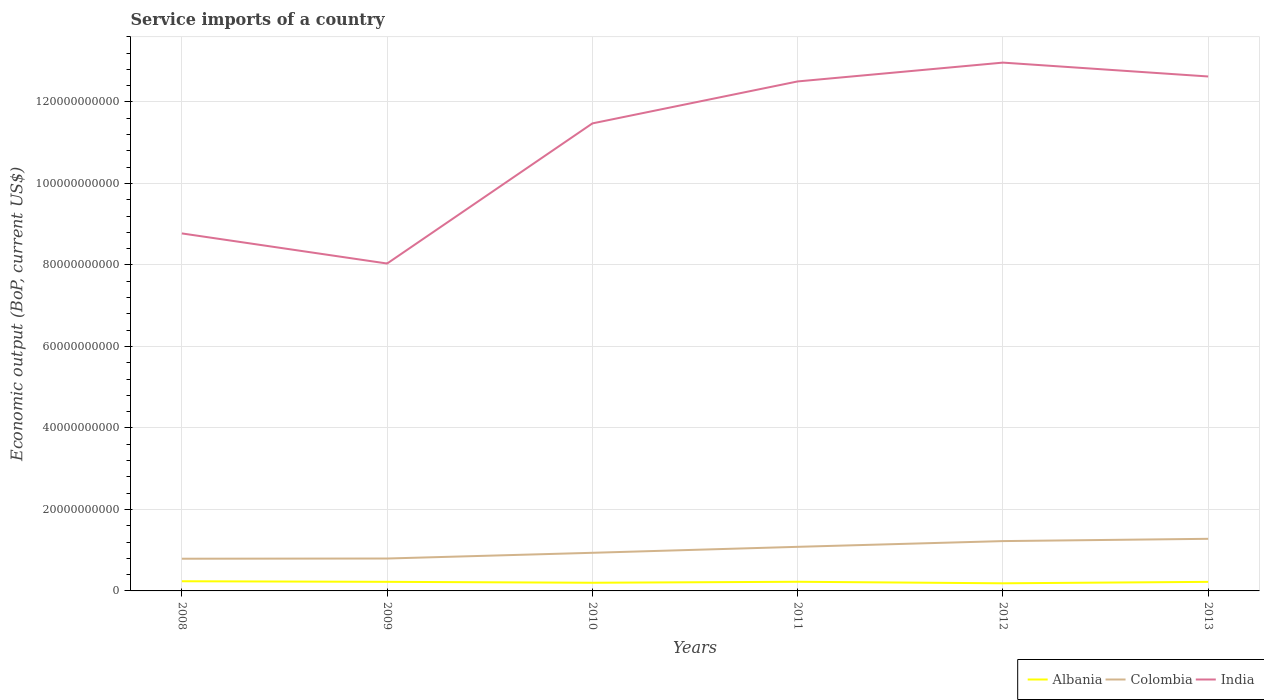How many different coloured lines are there?
Offer a terse response. 3. Does the line corresponding to India intersect with the line corresponding to Albania?
Provide a short and direct response. No. Is the number of lines equal to the number of legend labels?
Your answer should be compact. Yes. Across all years, what is the maximum service imports in India?
Your answer should be compact. 8.03e+1. What is the total service imports in India in the graph?
Make the answer very short. -4.59e+1. What is the difference between the highest and the second highest service imports in Albania?
Give a very brief answer. 5.01e+08. What is the difference between the highest and the lowest service imports in Colombia?
Offer a very short reply. 3. How many lines are there?
Your response must be concise. 3. How many years are there in the graph?
Provide a short and direct response. 6. Are the values on the major ticks of Y-axis written in scientific E-notation?
Ensure brevity in your answer.  No. Does the graph contain any zero values?
Make the answer very short. No. Where does the legend appear in the graph?
Your answer should be compact. Bottom right. How many legend labels are there?
Your answer should be compact. 3. What is the title of the graph?
Provide a succinct answer. Service imports of a country. Does "Equatorial Guinea" appear as one of the legend labels in the graph?
Ensure brevity in your answer.  No. What is the label or title of the Y-axis?
Offer a terse response. Economic output (BoP, current US$). What is the Economic output (BoP, current US$) in Albania in 2008?
Provide a short and direct response. 2.37e+09. What is the Economic output (BoP, current US$) of Colombia in 2008?
Provide a succinct answer. 7.90e+09. What is the Economic output (BoP, current US$) in India in 2008?
Your answer should be compact. 8.77e+1. What is the Economic output (BoP, current US$) of Albania in 2009?
Provide a short and direct response. 2.23e+09. What is the Economic output (BoP, current US$) of Colombia in 2009?
Your answer should be very brief. 7.95e+09. What is the Economic output (BoP, current US$) in India in 2009?
Keep it short and to the point. 8.03e+1. What is the Economic output (BoP, current US$) of Albania in 2010?
Give a very brief answer. 2.01e+09. What is the Economic output (BoP, current US$) of Colombia in 2010?
Your answer should be compact. 9.36e+09. What is the Economic output (BoP, current US$) in India in 2010?
Provide a succinct answer. 1.15e+11. What is the Economic output (BoP, current US$) in Albania in 2011?
Ensure brevity in your answer.  2.25e+09. What is the Economic output (BoP, current US$) in Colombia in 2011?
Your answer should be very brief. 1.08e+1. What is the Economic output (BoP, current US$) in India in 2011?
Offer a terse response. 1.25e+11. What is the Economic output (BoP, current US$) of Albania in 2012?
Keep it short and to the point. 1.87e+09. What is the Economic output (BoP, current US$) of Colombia in 2012?
Provide a succinct answer. 1.22e+1. What is the Economic output (BoP, current US$) in India in 2012?
Ensure brevity in your answer.  1.30e+11. What is the Economic output (BoP, current US$) of Albania in 2013?
Make the answer very short. 2.23e+09. What is the Economic output (BoP, current US$) of Colombia in 2013?
Your answer should be very brief. 1.28e+1. What is the Economic output (BoP, current US$) of India in 2013?
Offer a terse response. 1.26e+11. Across all years, what is the maximum Economic output (BoP, current US$) of Albania?
Ensure brevity in your answer.  2.37e+09. Across all years, what is the maximum Economic output (BoP, current US$) of Colombia?
Make the answer very short. 1.28e+1. Across all years, what is the maximum Economic output (BoP, current US$) of India?
Offer a very short reply. 1.30e+11. Across all years, what is the minimum Economic output (BoP, current US$) in Albania?
Make the answer very short. 1.87e+09. Across all years, what is the minimum Economic output (BoP, current US$) of Colombia?
Offer a very short reply. 7.90e+09. Across all years, what is the minimum Economic output (BoP, current US$) of India?
Offer a very short reply. 8.03e+1. What is the total Economic output (BoP, current US$) of Albania in the graph?
Give a very brief answer. 1.30e+1. What is the total Economic output (BoP, current US$) in Colombia in the graph?
Keep it short and to the point. 6.11e+1. What is the total Economic output (BoP, current US$) in India in the graph?
Ensure brevity in your answer.  6.64e+11. What is the difference between the Economic output (BoP, current US$) of Albania in 2008 and that in 2009?
Ensure brevity in your answer.  1.40e+08. What is the difference between the Economic output (BoP, current US$) in Colombia in 2008 and that in 2009?
Provide a short and direct response. -5.14e+07. What is the difference between the Economic output (BoP, current US$) in India in 2008 and that in 2009?
Keep it short and to the point. 7.39e+09. What is the difference between the Economic output (BoP, current US$) in Albania in 2008 and that in 2010?
Offer a very short reply. 3.65e+08. What is the difference between the Economic output (BoP, current US$) of Colombia in 2008 and that in 2010?
Ensure brevity in your answer.  -1.45e+09. What is the difference between the Economic output (BoP, current US$) of India in 2008 and that in 2010?
Make the answer very short. -2.70e+1. What is the difference between the Economic output (BoP, current US$) of Albania in 2008 and that in 2011?
Ensure brevity in your answer.  1.24e+08. What is the difference between the Economic output (BoP, current US$) in Colombia in 2008 and that in 2011?
Offer a very short reply. -2.92e+09. What is the difference between the Economic output (BoP, current US$) in India in 2008 and that in 2011?
Your answer should be compact. -3.73e+1. What is the difference between the Economic output (BoP, current US$) in Albania in 2008 and that in 2012?
Your response must be concise. 5.01e+08. What is the difference between the Economic output (BoP, current US$) in Colombia in 2008 and that in 2012?
Keep it short and to the point. -4.33e+09. What is the difference between the Economic output (BoP, current US$) of India in 2008 and that in 2012?
Keep it short and to the point. -4.19e+1. What is the difference between the Economic output (BoP, current US$) of Albania in 2008 and that in 2013?
Your answer should be very brief. 1.47e+08. What is the difference between the Economic output (BoP, current US$) of Colombia in 2008 and that in 2013?
Provide a short and direct response. -4.89e+09. What is the difference between the Economic output (BoP, current US$) of India in 2008 and that in 2013?
Give a very brief answer. -3.85e+1. What is the difference between the Economic output (BoP, current US$) in Albania in 2009 and that in 2010?
Ensure brevity in your answer.  2.26e+08. What is the difference between the Economic output (BoP, current US$) in Colombia in 2009 and that in 2010?
Give a very brief answer. -1.40e+09. What is the difference between the Economic output (BoP, current US$) of India in 2009 and that in 2010?
Your answer should be compact. -3.44e+1. What is the difference between the Economic output (BoP, current US$) of Albania in 2009 and that in 2011?
Your answer should be very brief. -1.58e+07. What is the difference between the Economic output (BoP, current US$) in Colombia in 2009 and that in 2011?
Offer a very short reply. -2.87e+09. What is the difference between the Economic output (BoP, current US$) in India in 2009 and that in 2011?
Offer a terse response. -4.47e+1. What is the difference between the Economic output (BoP, current US$) of Albania in 2009 and that in 2012?
Provide a succinct answer. 3.61e+08. What is the difference between the Economic output (BoP, current US$) in Colombia in 2009 and that in 2012?
Your response must be concise. -4.28e+09. What is the difference between the Economic output (BoP, current US$) of India in 2009 and that in 2012?
Your answer should be very brief. -4.93e+1. What is the difference between the Economic output (BoP, current US$) of Albania in 2009 and that in 2013?
Ensure brevity in your answer.  7.36e+06. What is the difference between the Economic output (BoP, current US$) in Colombia in 2009 and that in 2013?
Ensure brevity in your answer.  -4.83e+09. What is the difference between the Economic output (BoP, current US$) in India in 2009 and that in 2013?
Offer a terse response. -4.59e+1. What is the difference between the Economic output (BoP, current US$) of Albania in 2010 and that in 2011?
Keep it short and to the point. -2.42e+08. What is the difference between the Economic output (BoP, current US$) of Colombia in 2010 and that in 2011?
Your answer should be compact. -1.47e+09. What is the difference between the Economic output (BoP, current US$) in India in 2010 and that in 2011?
Provide a succinct answer. -1.03e+1. What is the difference between the Economic output (BoP, current US$) of Albania in 2010 and that in 2012?
Your response must be concise. 1.36e+08. What is the difference between the Economic output (BoP, current US$) in Colombia in 2010 and that in 2012?
Give a very brief answer. -2.87e+09. What is the difference between the Economic output (BoP, current US$) in India in 2010 and that in 2012?
Ensure brevity in your answer.  -1.49e+1. What is the difference between the Economic output (BoP, current US$) of Albania in 2010 and that in 2013?
Offer a terse response. -2.18e+08. What is the difference between the Economic output (BoP, current US$) in Colombia in 2010 and that in 2013?
Your answer should be very brief. -3.43e+09. What is the difference between the Economic output (BoP, current US$) in India in 2010 and that in 2013?
Give a very brief answer. -1.15e+1. What is the difference between the Economic output (BoP, current US$) of Albania in 2011 and that in 2012?
Ensure brevity in your answer.  3.77e+08. What is the difference between the Economic output (BoP, current US$) in Colombia in 2011 and that in 2012?
Provide a succinct answer. -1.41e+09. What is the difference between the Economic output (BoP, current US$) of India in 2011 and that in 2012?
Keep it short and to the point. -4.62e+09. What is the difference between the Economic output (BoP, current US$) of Albania in 2011 and that in 2013?
Keep it short and to the point. 2.32e+07. What is the difference between the Economic output (BoP, current US$) of Colombia in 2011 and that in 2013?
Provide a short and direct response. -1.97e+09. What is the difference between the Economic output (BoP, current US$) of India in 2011 and that in 2013?
Give a very brief answer. -1.22e+09. What is the difference between the Economic output (BoP, current US$) of Albania in 2012 and that in 2013?
Your response must be concise. -3.54e+08. What is the difference between the Economic output (BoP, current US$) in Colombia in 2012 and that in 2013?
Your response must be concise. -5.59e+08. What is the difference between the Economic output (BoP, current US$) of India in 2012 and that in 2013?
Provide a short and direct response. 3.40e+09. What is the difference between the Economic output (BoP, current US$) of Albania in 2008 and the Economic output (BoP, current US$) of Colombia in 2009?
Offer a terse response. -5.58e+09. What is the difference between the Economic output (BoP, current US$) of Albania in 2008 and the Economic output (BoP, current US$) of India in 2009?
Give a very brief answer. -7.80e+1. What is the difference between the Economic output (BoP, current US$) in Colombia in 2008 and the Economic output (BoP, current US$) in India in 2009?
Give a very brief answer. -7.24e+1. What is the difference between the Economic output (BoP, current US$) of Albania in 2008 and the Economic output (BoP, current US$) of Colombia in 2010?
Your response must be concise. -6.98e+09. What is the difference between the Economic output (BoP, current US$) of Albania in 2008 and the Economic output (BoP, current US$) of India in 2010?
Your response must be concise. -1.12e+11. What is the difference between the Economic output (BoP, current US$) of Colombia in 2008 and the Economic output (BoP, current US$) of India in 2010?
Your response must be concise. -1.07e+11. What is the difference between the Economic output (BoP, current US$) in Albania in 2008 and the Economic output (BoP, current US$) in Colombia in 2011?
Make the answer very short. -8.45e+09. What is the difference between the Economic output (BoP, current US$) of Albania in 2008 and the Economic output (BoP, current US$) of India in 2011?
Your response must be concise. -1.23e+11. What is the difference between the Economic output (BoP, current US$) in Colombia in 2008 and the Economic output (BoP, current US$) in India in 2011?
Your response must be concise. -1.17e+11. What is the difference between the Economic output (BoP, current US$) of Albania in 2008 and the Economic output (BoP, current US$) of Colombia in 2012?
Ensure brevity in your answer.  -9.86e+09. What is the difference between the Economic output (BoP, current US$) in Albania in 2008 and the Economic output (BoP, current US$) in India in 2012?
Keep it short and to the point. -1.27e+11. What is the difference between the Economic output (BoP, current US$) in Colombia in 2008 and the Economic output (BoP, current US$) in India in 2012?
Your answer should be very brief. -1.22e+11. What is the difference between the Economic output (BoP, current US$) of Albania in 2008 and the Economic output (BoP, current US$) of Colombia in 2013?
Offer a terse response. -1.04e+1. What is the difference between the Economic output (BoP, current US$) of Albania in 2008 and the Economic output (BoP, current US$) of India in 2013?
Ensure brevity in your answer.  -1.24e+11. What is the difference between the Economic output (BoP, current US$) of Colombia in 2008 and the Economic output (BoP, current US$) of India in 2013?
Your response must be concise. -1.18e+11. What is the difference between the Economic output (BoP, current US$) in Albania in 2009 and the Economic output (BoP, current US$) in Colombia in 2010?
Provide a short and direct response. -7.12e+09. What is the difference between the Economic output (BoP, current US$) of Albania in 2009 and the Economic output (BoP, current US$) of India in 2010?
Your answer should be very brief. -1.13e+11. What is the difference between the Economic output (BoP, current US$) of Colombia in 2009 and the Economic output (BoP, current US$) of India in 2010?
Offer a very short reply. -1.07e+11. What is the difference between the Economic output (BoP, current US$) in Albania in 2009 and the Economic output (BoP, current US$) in Colombia in 2011?
Provide a succinct answer. -8.59e+09. What is the difference between the Economic output (BoP, current US$) of Albania in 2009 and the Economic output (BoP, current US$) of India in 2011?
Give a very brief answer. -1.23e+11. What is the difference between the Economic output (BoP, current US$) in Colombia in 2009 and the Economic output (BoP, current US$) in India in 2011?
Your answer should be compact. -1.17e+11. What is the difference between the Economic output (BoP, current US$) in Albania in 2009 and the Economic output (BoP, current US$) in Colombia in 2012?
Offer a terse response. -1.00e+1. What is the difference between the Economic output (BoP, current US$) in Albania in 2009 and the Economic output (BoP, current US$) in India in 2012?
Make the answer very short. -1.27e+11. What is the difference between the Economic output (BoP, current US$) of Colombia in 2009 and the Economic output (BoP, current US$) of India in 2012?
Provide a short and direct response. -1.22e+11. What is the difference between the Economic output (BoP, current US$) of Albania in 2009 and the Economic output (BoP, current US$) of Colombia in 2013?
Provide a succinct answer. -1.06e+1. What is the difference between the Economic output (BoP, current US$) of Albania in 2009 and the Economic output (BoP, current US$) of India in 2013?
Provide a short and direct response. -1.24e+11. What is the difference between the Economic output (BoP, current US$) of Colombia in 2009 and the Economic output (BoP, current US$) of India in 2013?
Make the answer very short. -1.18e+11. What is the difference between the Economic output (BoP, current US$) of Albania in 2010 and the Economic output (BoP, current US$) of Colombia in 2011?
Provide a succinct answer. -8.82e+09. What is the difference between the Economic output (BoP, current US$) of Albania in 2010 and the Economic output (BoP, current US$) of India in 2011?
Provide a short and direct response. -1.23e+11. What is the difference between the Economic output (BoP, current US$) of Colombia in 2010 and the Economic output (BoP, current US$) of India in 2011?
Offer a very short reply. -1.16e+11. What is the difference between the Economic output (BoP, current US$) in Albania in 2010 and the Economic output (BoP, current US$) in Colombia in 2012?
Keep it short and to the point. -1.02e+1. What is the difference between the Economic output (BoP, current US$) in Albania in 2010 and the Economic output (BoP, current US$) in India in 2012?
Offer a terse response. -1.28e+11. What is the difference between the Economic output (BoP, current US$) of Colombia in 2010 and the Economic output (BoP, current US$) of India in 2012?
Your answer should be compact. -1.20e+11. What is the difference between the Economic output (BoP, current US$) of Albania in 2010 and the Economic output (BoP, current US$) of Colombia in 2013?
Keep it short and to the point. -1.08e+1. What is the difference between the Economic output (BoP, current US$) in Albania in 2010 and the Economic output (BoP, current US$) in India in 2013?
Give a very brief answer. -1.24e+11. What is the difference between the Economic output (BoP, current US$) of Colombia in 2010 and the Economic output (BoP, current US$) of India in 2013?
Your answer should be compact. -1.17e+11. What is the difference between the Economic output (BoP, current US$) of Albania in 2011 and the Economic output (BoP, current US$) of Colombia in 2012?
Ensure brevity in your answer.  -9.98e+09. What is the difference between the Economic output (BoP, current US$) in Albania in 2011 and the Economic output (BoP, current US$) in India in 2012?
Make the answer very short. -1.27e+11. What is the difference between the Economic output (BoP, current US$) in Colombia in 2011 and the Economic output (BoP, current US$) in India in 2012?
Offer a very short reply. -1.19e+11. What is the difference between the Economic output (BoP, current US$) in Albania in 2011 and the Economic output (BoP, current US$) in Colombia in 2013?
Your response must be concise. -1.05e+1. What is the difference between the Economic output (BoP, current US$) in Albania in 2011 and the Economic output (BoP, current US$) in India in 2013?
Keep it short and to the point. -1.24e+11. What is the difference between the Economic output (BoP, current US$) of Colombia in 2011 and the Economic output (BoP, current US$) of India in 2013?
Your answer should be compact. -1.15e+11. What is the difference between the Economic output (BoP, current US$) in Albania in 2012 and the Economic output (BoP, current US$) in Colombia in 2013?
Give a very brief answer. -1.09e+1. What is the difference between the Economic output (BoP, current US$) in Albania in 2012 and the Economic output (BoP, current US$) in India in 2013?
Provide a succinct answer. -1.24e+11. What is the difference between the Economic output (BoP, current US$) of Colombia in 2012 and the Economic output (BoP, current US$) of India in 2013?
Provide a succinct answer. -1.14e+11. What is the average Economic output (BoP, current US$) in Albania per year?
Offer a very short reply. 2.16e+09. What is the average Economic output (BoP, current US$) of Colombia per year?
Provide a short and direct response. 1.02e+1. What is the average Economic output (BoP, current US$) of India per year?
Offer a very short reply. 1.11e+11. In the year 2008, what is the difference between the Economic output (BoP, current US$) of Albania and Economic output (BoP, current US$) of Colombia?
Offer a terse response. -5.53e+09. In the year 2008, what is the difference between the Economic output (BoP, current US$) of Albania and Economic output (BoP, current US$) of India?
Your answer should be compact. -8.54e+1. In the year 2008, what is the difference between the Economic output (BoP, current US$) in Colombia and Economic output (BoP, current US$) in India?
Keep it short and to the point. -7.98e+1. In the year 2009, what is the difference between the Economic output (BoP, current US$) in Albania and Economic output (BoP, current US$) in Colombia?
Give a very brief answer. -5.72e+09. In the year 2009, what is the difference between the Economic output (BoP, current US$) of Albania and Economic output (BoP, current US$) of India?
Ensure brevity in your answer.  -7.81e+1. In the year 2009, what is the difference between the Economic output (BoP, current US$) of Colombia and Economic output (BoP, current US$) of India?
Keep it short and to the point. -7.24e+1. In the year 2010, what is the difference between the Economic output (BoP, current US$) of Albania and Economic output (BoP, current US$) of Colombia?
Keep it short and to the point. -7.35e+09. In the year 2010, what is the difference between the Economic output (BoP, current US$) in Albania and Economic output (BoP, current US$) in India?
Provide a short and direct response. -1.13e+11. In the year 2010, what is the difference between the Economic output (BoP, current US$) of Colombia and Economic output (BoP, current US$) of India?
Keep it short and to the point. -1.05e+11. In the year 2011, what is the difference between the Economic output (BoP, current US$) in Albania and Economic output (BoP, current US$) in Colombia?
Provide a short and direct response. -8.57e+09. In the year 2011, what is the difference between the Economic output (BoP, current US$) in Albania and Economic output (BoP, current US$) in India?
Offer a very short reply. -1.23e+11. In the year 2011, what is the difference between the Economic output (BoP, current US$) in Colombia and Economic output (BoP, current US$) in India?
Make the answer very short. -1.14e+11. In the year 2012, what is the difference between the Economic output (BoP, current US$) of Albania and Economic output (BoP, current US$) of Colombia?
Offer a very short reply. -1.04e+1. In the year 2012, what is the difference between the Economic output (BoP, current US$) in Albania and Economic output (BoP, current US$) in India?
Make the answer very short. -1.28e+11. In the year 2012, what is the difference between the Economic output (BoP, current US$) in Colombia and Economic output (BoP, current US$) in India?
Your response must be concise. -1.17e+11. In the year 2013, what is the difference between the Economic output (BoP, current US$) in Albania and Economic output (BoP, current US$) in Colombia?
Your answer should be very brief. -1.06e+1. In the year 2013, what is the difference between the Economic output (BoP, current US$) in Albania and Economic output (BoP, current US$) in India?
Provide a succinct answer. -1.24e+11. In the year 2013, what is the difference between the Economic output (BoP, current US$) in Colombia and Economic output (BoP, current US$) in India?
Your response must be concise. -1.13e+11. What is the ratio of the Economic output (BoP, current US$) in India in 2008 to that in 2009?
Make the answer very short. 1.09. What is the ratio of the Economic output (BoP, current US$) of Albania in 2008 to that in 2010?
Offer a terse response. 1.18. What is the ratio of the Economic output (BoP, current US$) of Colombia in 2008 to that in 2010?
Offer a very short reply. 0.84. What is the ratio of the Economic output (BoP, current US$) in India in 2008 to that in 2010?
Keep it short and to the point. 0.76. What is the ratio of the Economic output (BoP, current US$) in Albania in 2008 to that in 2011?
Give a very brief answer. 1.06. What is the ratio of the Economic output (BoP, current US$) in Colombia in 2008 to that in 2011?
Ensure brevity in your answer.  0.73. What is the ratio of the Economic output (BoP, current US$) in India in 2008 to that in 2011?
Your response must be concise. 0.7. What is the ratio of the Economic output (BoP, current US$) of Albania in 2008 to that in 2012?
Offer a very short reply. 1.27. What is the ratio of the Economic output (BoP, current US$) in Colombia in 2008 to that in 2012?
Offer a terse response. 0.65. What is the ratio of the Economic output (BoP, current US$) of India in 2008 to that in 2012?
Give a very brief answer. 0.68. What is the ratio of the Economic output (BoP, current US$) in Albania in 2008 to that in 2013?
Offer a terse response. 1.07. What is the ratio of the Economic output (BoP, current US$) in Colombia in 2008 to that in 2013?
Offer a very short reply. 0.62. What is the ratio of the Economic output (BoP, current US$) of India in 2008 to that in 2013?
Provide a short and direct response. 0.69. What is the ratio of the Economic output (BoP, current US$) in Albania in 2009 to that in 2010?
Provide a succinct answer. 1.11. What is the ratio of the Economic output (BoP, current US$) in Colombia in 2009 to that in 2010?
Your answer should be compact. 0.85. What is the ratio of the Economic output (BoP, current US$) of India in 2009 to that in 2010?
Provide a short and direct response. 0.7. What is the ratio of the Economic output (BoP, current US$) of Albania in 2009 to that in 2011?
Ensure brevity in your answer.  0.99. What is the ratio of the Economic output (BoP, current US$) of Colombia in 2009 to that in 2011?
Provide a short and direct response. 0.73. What is the ratio of the Economic output (BoP, current US$) in India in 2009 to that in 2011?
Offer a very short reply. 0.64. What is the ratio of the Economic output (BoP, current US$) in Albania in 2009 to that in 2012?
Give a very brief answer. 1.19. What is the ratio of the Economic output (BoP, current US$) in Colombia in 2009 to that in 2012?
Offer a terse response. 0.65. What is the ratio of the Economic output (BoP, current US$) in India in 2009 to that in 2012?
Your response must be concise. 0.62. What is the ratio of the Economic output (BoP, current US$) in Colombia in 2009 to that in 2013?
Your answer should be compact. 0.62. What is the ratio of the Economic output (BoP, current US$) of India in 2009 to that in 2013?
Make the answer very short. 0.64. What is the ratio of the Economic output (BoP, current US$) in Albania in 2010 to that in 2011?
Offer a very short reply. 0.89. What is the ratio of the Economic output (BoP, current US$) in Colombia in 2010 to that in 2011?
Your answer should be very brief. 0.86. What is the ratio of the Economic output (BoP, current US$) in India in 2010 to that in 2011?
Give a very brief answer. 0.92. What is the ratio of the Economic output (BoP, current US$) of Albania in 2010 to that in 2012?
Your response must be concise. 1.07. What is the ratio of the Economic output (BoP, current US$) in Colombia in 2010 to that in 2012?
Provide a short and direct response. 0.77. What is the ratio of the Economic output (BoP, current US$) of India in 2010 to that in 2012?
Ensure brevity in your answer.  0.88. What is the ratio of the Economic output (BoP, current US$) of Albania in 2010 to that in 2013?
Offer a terse response. 0.9. What is the ratio of the Economic output (BoP, current US$) in Colombia in 2010 to that in 2013?
Your answer should be compact. 0.73. What is the ratio of the Economic output (BoP, current US$) of India in 2010 to that in 2013?
Give a very brief answer. 0.91. What is the ratio of the Economic output (BoP, current US$) in Albania in 2011 to that in 2012?
Your response must be concise. 1.2. What is the ratio of the Economic output (BoP, current US$) in Colombia in 2011 to that in 2012?
Provide a succinct answer. 0.89. What is the ratio of the Economic output (BoP, current US$) of India in 2011 to that in 2012?
Give a very brief answer. 0.96. What is the ratio of the Economic output (BoP, current US$) of Albania in 2011 to that in 2013?
Keep it short and to the point. 1.01. What is the ratio of the Economic output (BoP, current US$) of Colombia in 2011 to that in 2013?
Keep it short and to the point. 0.85. What is the ratio of the Economic output (BoP, current US$) of Albania in 2012 to that in 2013?
Make the answer very short. 0.84. What is the ratio of the Economic output (BoP, current US$) of Colombia in 2012 to that in 2013?
Offer a terse response. 0.96. What is the ratio of the Economic output (BoP, current US$) in India in 2012 to that in 2013?
Give a very brief answer. 1.03. What is the difference between the highest and the second highest Economic output (BoP, current US$) of Albania?
Your response must be concise. 1.24e+08. What is the difference between the highest and the second highest Economic output (BoP, current US$) of Colombia?
Your answer should be compact. 5.59e+08. What is the difference between the highest and the second highest Economic output (BoP, current US$) of India?
Your response must be concise. 3.40e+09. What is the difference between the highest and the lowest Economic output (BoP, current US$) in Albania?
Offer a very short reply. 5.01e+08. What is the difference between the highest and the lowest Economic output (BoP, current US$) of Colombia?
Your answer should be compact. 4.89e+09. What is the difference between the highest and the lowest Economic output (BoP, current US$) of India?
Provide a succinct answer. 4.93e+1. 